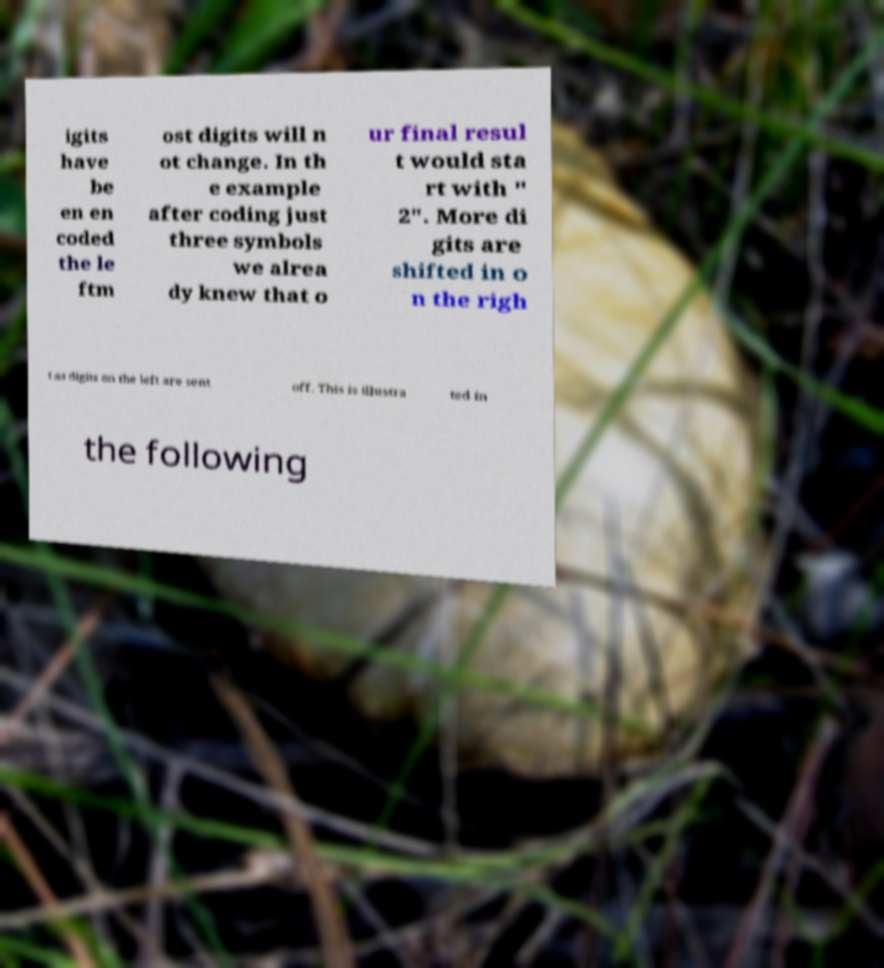Could you assist in decoding the text presented in this image and type it out clearly? igits have be en en coded the le ftm ost digits will n ot change. In th e example after coding just three symbols we alrea dy knew that o ur final resul t would sta rt with " 2". More di gits are shifted in o n the righ t as digits on the left are sent off. This is illustra ted in the following 